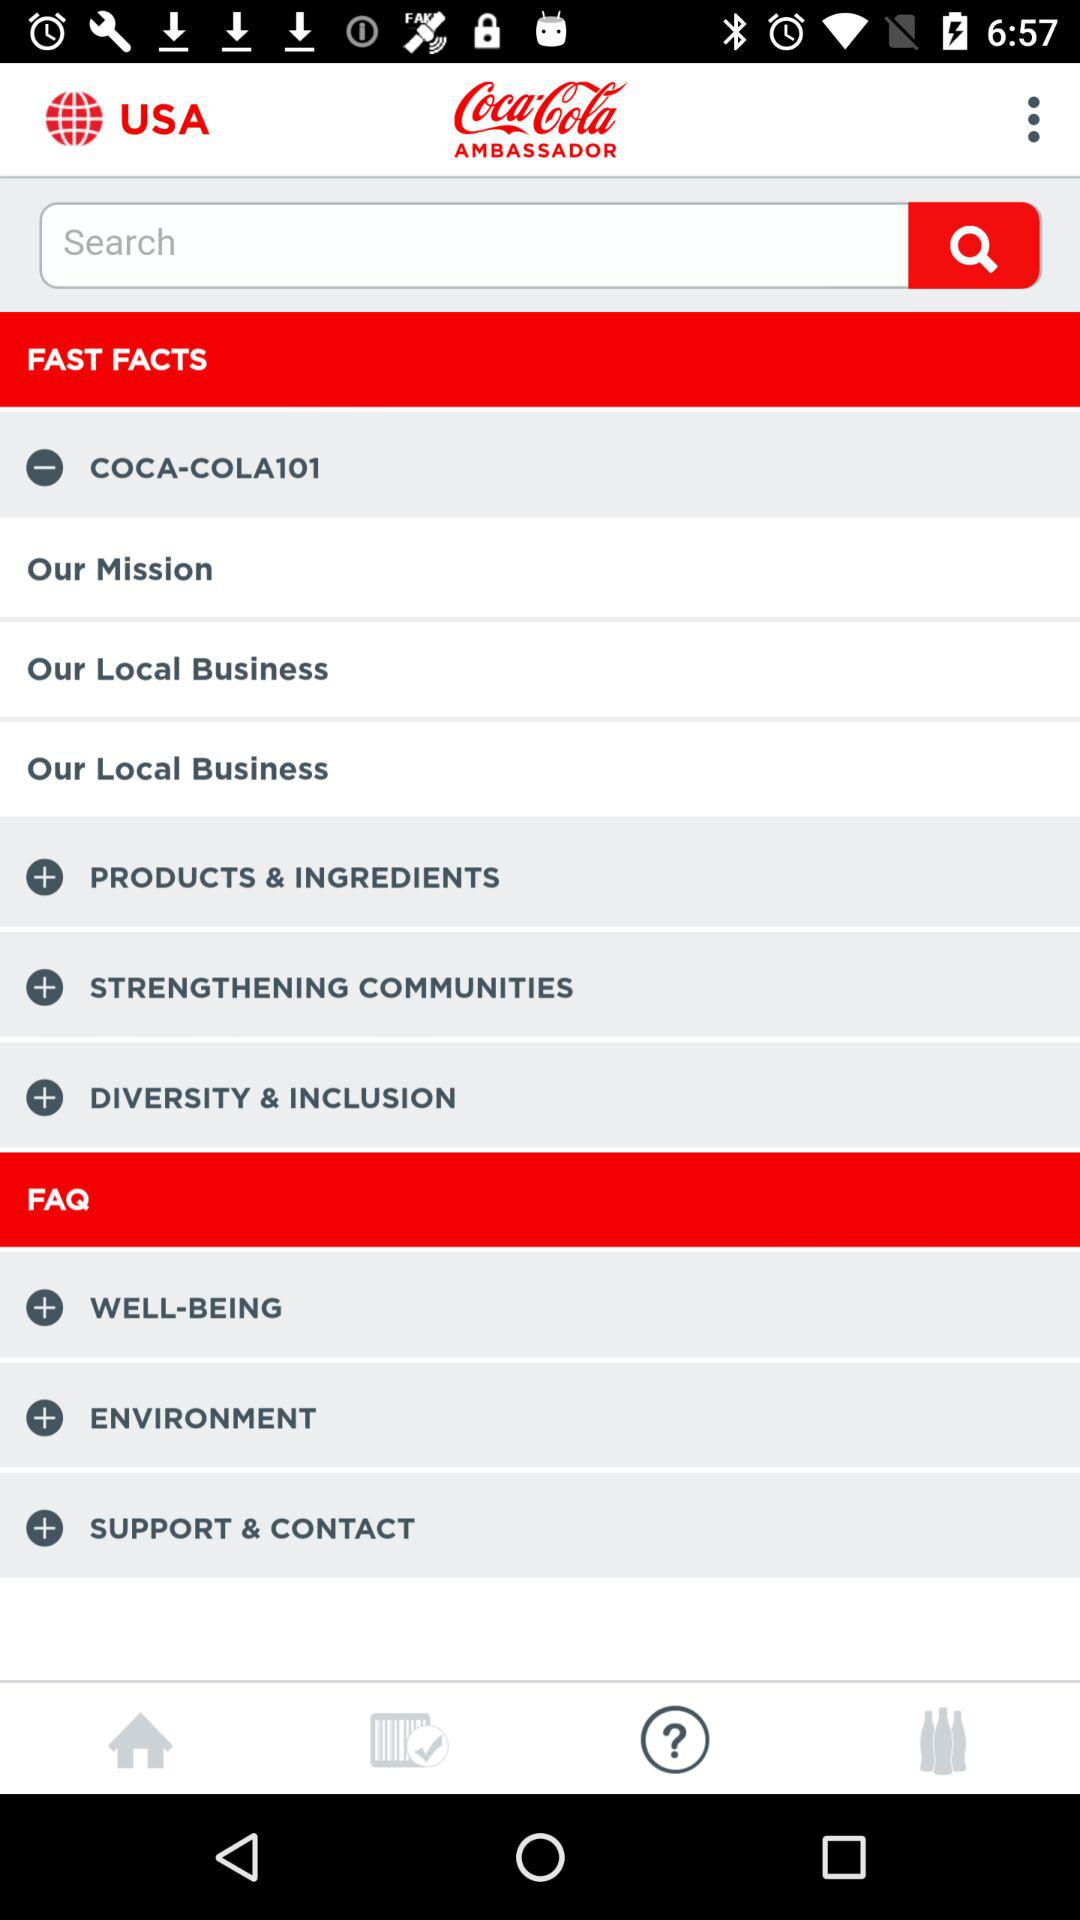What is the name of the application? The application name is "Coca-Cola AMBASSADOR". 